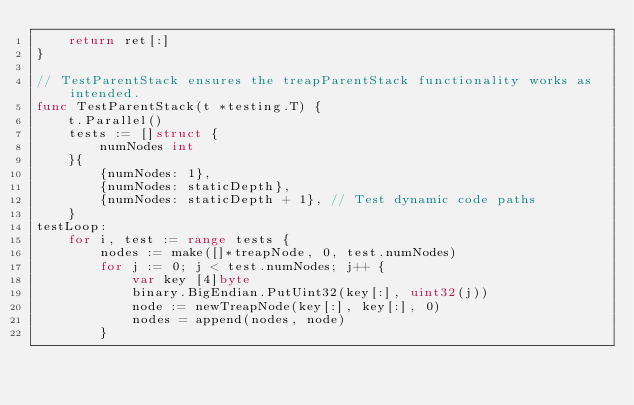<code> <loc_0><loc_0><loc_500><loc_500><_Go_>	return ret[:]
}

// TestParentStack ensures the treapParentStack functionality works as intended.
func TestParentStack(t *testing.T) {
	t.Parallel()
	tests := []struct {
		numNodes int
	}{
		{numNodes: 1},
		{numNodes: staticDepth},
		{numNodes: staticDepth + 1}, // Test dynamic code paths
	}
testLoop:
	for i, test := range tests {
		nodes := make([]*treapNode, 0, test.numNodes)
		for j := 0; j < test.numNodes; j++ {
			var key [4]byte
			binary.BigEndian.PutUint32(key[:], uint32(j))
			node := newTreapNode(key[:], key[:], 0)
			nodes = append(nodes, node)
		}</code> 